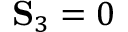Convert formula to latex. <formula><loc_0><loc_0><loc_500><loc_500>S _ { 3 } = 0</formula> 